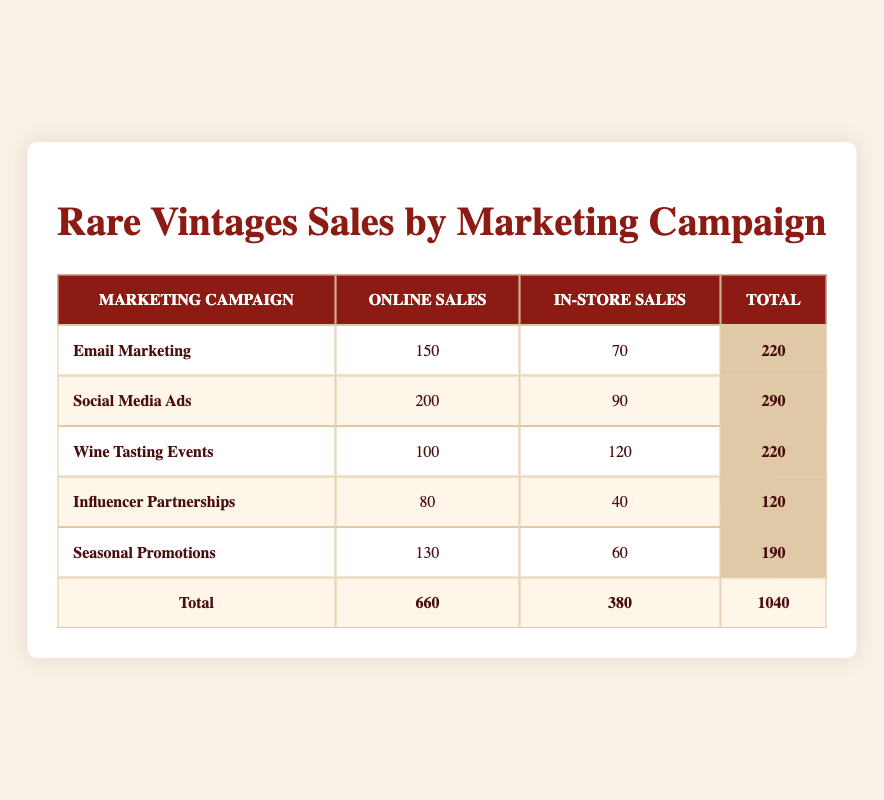What is the total number of online sales for all marketing campaigns? By adding the online sales of each campaign: 150 (Email Marketing) + 200 (Social Media Ads) + 100 (Wine Tasting Events) + 80 (Influencer Partnerships) + 130 (Seasonal Promotions) = 660
Answer: 660 Which marketing campaign had the highest in-store sales? Checking the in-store sales figures, we find that Wine Tasting Events has the highest sales at 120.
Answer: 120 What is the difference between online and in-store sales for the Social Media Ads campaign? Subtracting the in-store sales (90) from online sales (200) gives us a difference of 200 - 90 = 110.
Answer: 110 Is the total sales for Email Marketing greater than that for Influencer Partnerships? The total for Email Marketing is 220 (150 + 70) and for Influencer Partnerships is 120 (80 + 40). Since 220 is greater than 120, the statement is true.
Answer: Yes What percentage of total sales came from online sales? The total sales amount to 1040 (sum of all sales), and online sales are 660. The percentage is calculated as (660 / 1040) * 100, which equals approximately 63.46%.
Answer: 63.46% What is the average in-store sales per campaign? There are 5 campaigns, and the in-store sales sum is 70 + 90 + 120 + 40 + 60 = 380. Dividing this sum by 5 yields the average of 380 / 5 = 76.
Answer: 76 For which marketing campaign is the ratio of online to in-store sales the highest? Calculating the ratio for each campaign gives: Email Marketing (150/70 = 2.14), Social Media Ads (200/90 = 2.22), Wine Tasting Events (100/120 = 0.83), Influencer Partnerships (80/40 = 2.00), and Seasonal Promotions (130/60 = 2.17). The highest ratio is for Social Media Ads at approximately 2.22.
Answer: Social Media Ads How many more total sales did online channels have compared to in-store channels? Total online sales are 660 and total in-store sales are 380. The difference is 660 - 380 = 280 more sales for online channels.
Answer: 280 